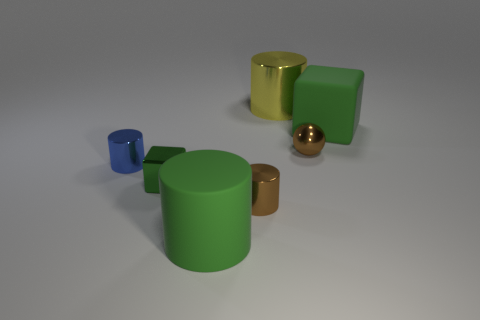Can you describe the lighting reflected on the golden cylinder? Certainly! The golden cylinder appears to have a soft reflection with diffuse lighting. The reflection is not sharp, indicating there isn't a strong direct light source, but rather ambient lighting providing a gentle glow on its metallic surface. 